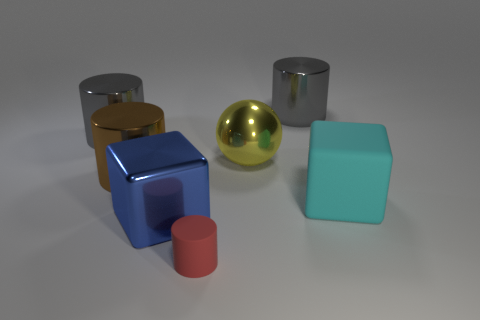Subtract all brown shiny cylinders. How many cylinders are left? 3 Subtract all blue spheres. How many gray cylinders are left? 2 Subtract all red cylinders. How many cylinders are left? 3 Subtract 2 cylinders. How many cylinders are left? 2 Add 1 large blue cubes. How many objects exist? 8 Subtract all cubes. How many objects are left? 5 Subtract all yellow cylinders. Subtract all red spheres. How many cylinders are left? 4 Subtract 0 purple cylinders. How many objects are left? 7 Subtract all large brown shiny spheres. Subtract all yellow spheres. How many objects are left? 6 Add 7 brown shiny cylinders. How many brown shiny cylinders are left? 8 